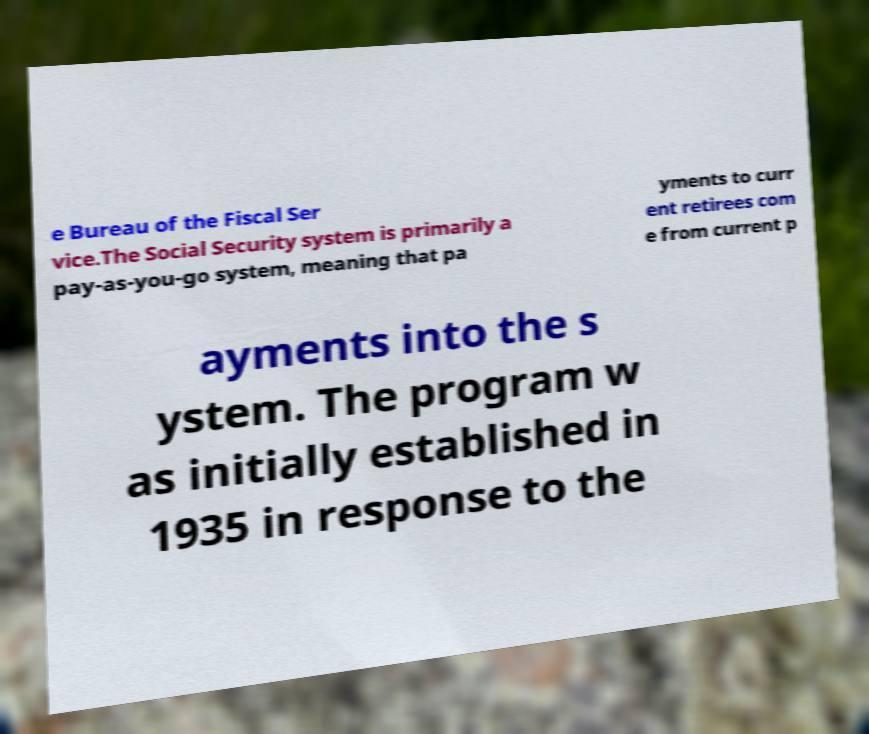Please identify and transcribe the text found in this image. e Bureau of the Fiscal Ser vice.The Social Security system is primarily a pay-as-you-go system, meaning that pa yments to curr ent retirees com e from current p ayments into the s ystem. The program w as initially established in 1935 in response to the 